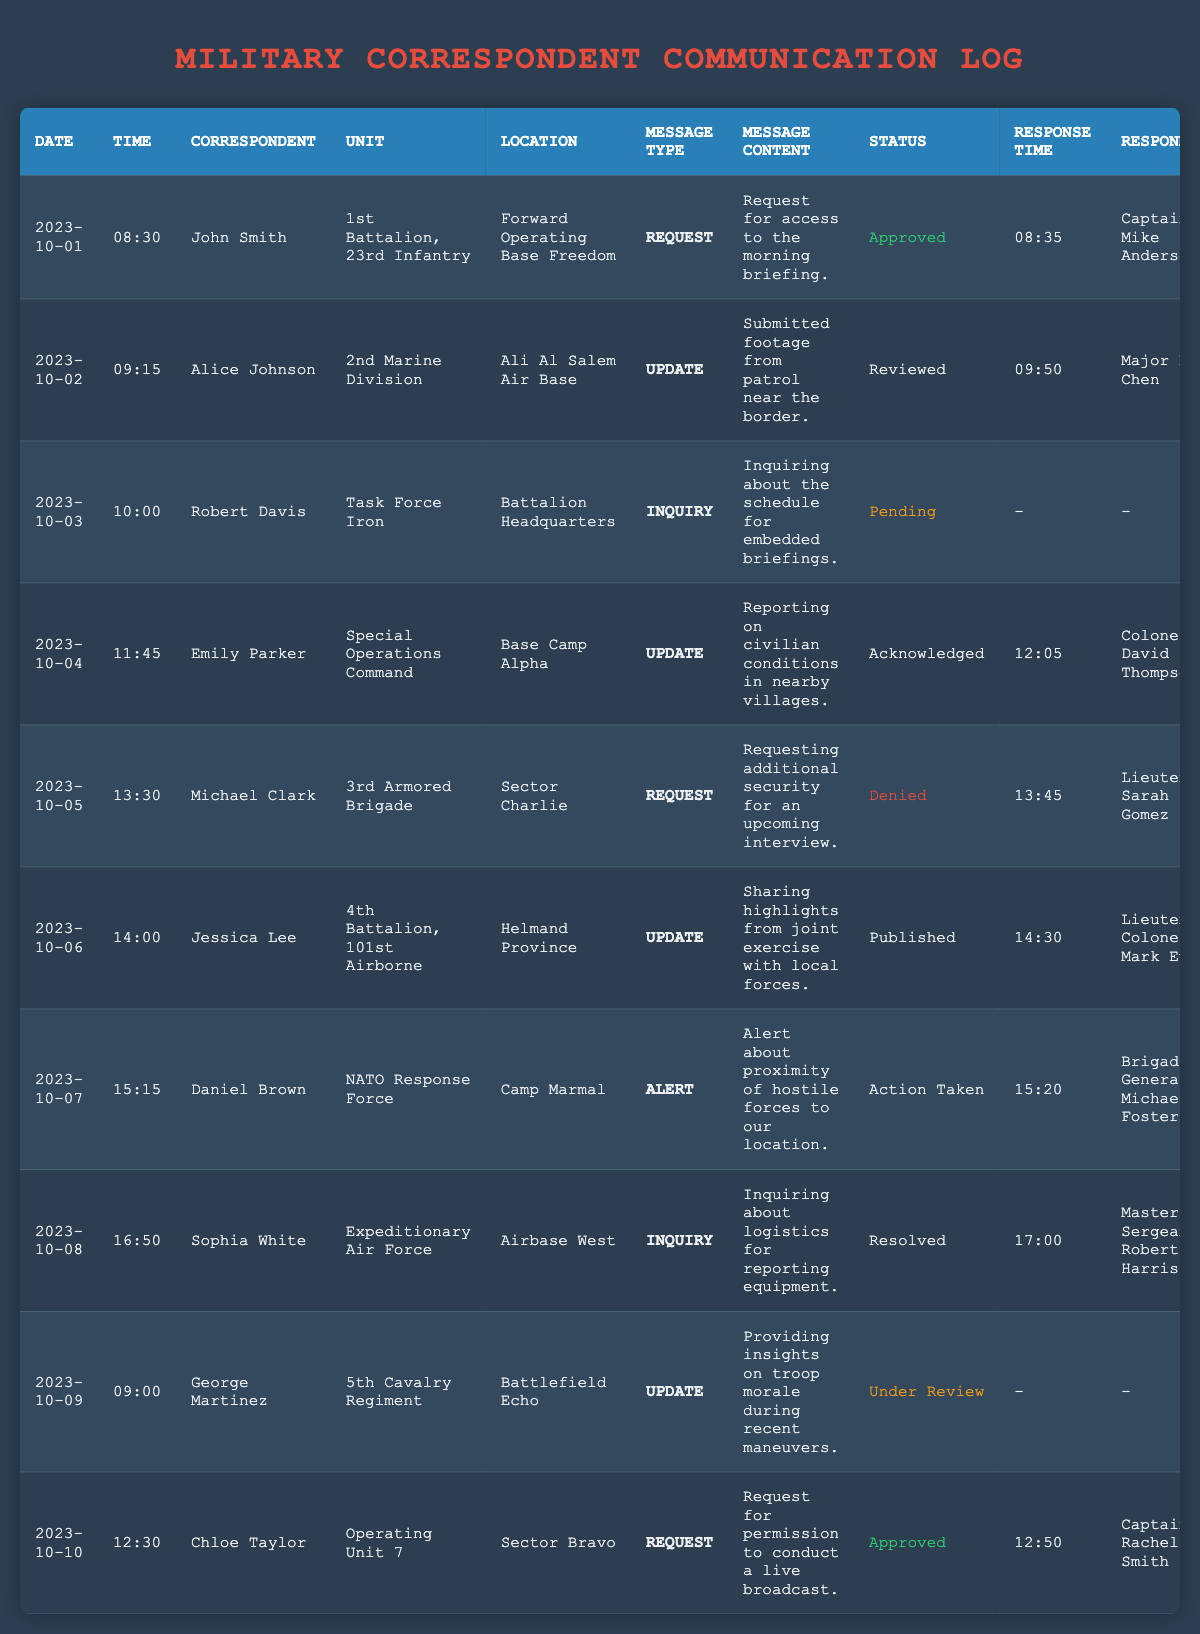What is the total number of requests made by correspondents? In the table, I can identify the message types. Scanning through the entries, I find that there are 3 occurrences where the message type is "Request": on October 1, 5, and 10. Therefore, the total number of requests is 3.
Answer: 3 Who approved the request made by John Smith? Looking at the entry for John Smith on October 1, I see that his request message was responded to by Captain Mike Anderson. Thus, Captain Mike Anderson approved his request.
Answer: Captain Mike Anderson What was the status of Robert Davis's inquiry? In the table, I locate the entry for Robert Davis on October 3. It specifies that the status of his inquiry is "Pending," indicating that no response has been registered yet.
Answer: Pending Did any correspondent report on civilian conditions? I can find in the table that on October 4, Emily Parker reported on civilian conditions, and the status of her message is "Acknowledged." Thus, the answer is affirmative.
Answer: Yes How many correspondents submitted an update? I review the entries and find that there are 4 updates: Alice Johnson on October 2, Emily Parker on October 4, Jessica Lee on October 6, and George Martinez on October 9. Summing these gives a total of 4 correspondents who submitted updates.
Answer: 4 Which correspondents received an approved response? By examining the table entries, I identify that John Smith and Chloe Taylor both received approved responses for their requests on October 1 and October 10, respectively. Therefore, the correspondents with approved responses are John Smith and Chloe Taylor.
Answer: John Smith, Chloe Taylor What is the response time for the update by Jessica Lee? Looking at the entry for Jessica Lee dated October 6, I can see her response time recorded as 14:30. Therefore, the response time for her update is clearly stated as 14:30.
Answer: 14:30 Which units had correspondents that made inquiries? Scanning the table, I see that there are 2 inquiries: Robert Davis from "Task Force Iron" on October 3 and Sophia White from "Expeditionary Air Force" on October 8. Hence, the units with correspondents who made inquiries are Task Force Iron and Expeditionary Air Force.
Answer: Task Force Iron, Expeditionary Air Force What is the response status for George Martinez's update? Referring to George Martinez's entry from October 9, I observe that the status is listed as "Under Review." This indicates that his update has not yet been concluded.
Answer: Under Review How many total alerts were sent by correspondents? In the table, I count that there is 1 alert from Daniel Brown on October 7. Hence, the total number of alerts sent is 1.
Answer: 1 What was the message content of the update submitted by Alice Johnson? Analyzing the entry for Alice Johnson on October 2, I find that the message content states: "Submitted footage from patrol near the border." This gives me the exact content of her update.
Answer: Submitted footage from patrol near the border 